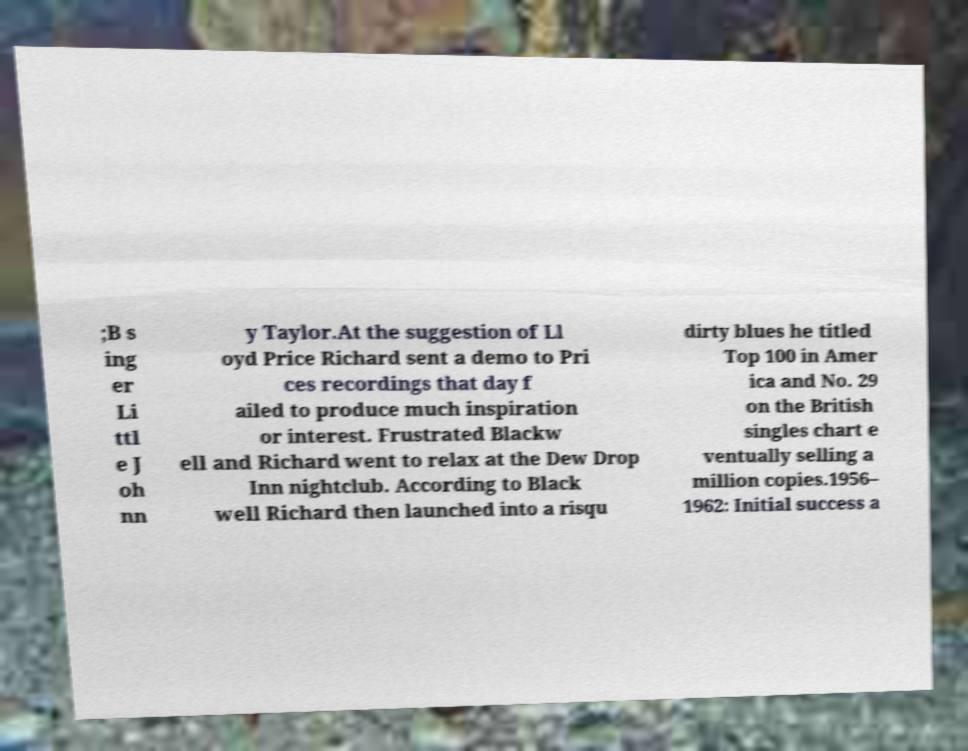What messages or text are displayed in this image? I need them in a readable, typed format. ;B s ing er Li ttl e J oh nn y Taylor.At the suggestion of Ll oyd Price Richard sent a demo to Pri ces recordings that day f ailed to produce much inspiration or interest. Frustrated Blackw ell and Richard went to relax at the Dew Drop Inn nightclub. According to Black well Richard then launched into a risqu dirty blues he titled Top 100 in Amer ica and No. 29 on the British singles chart e ventually selling a million copies.1956– 1962: Initial success a 